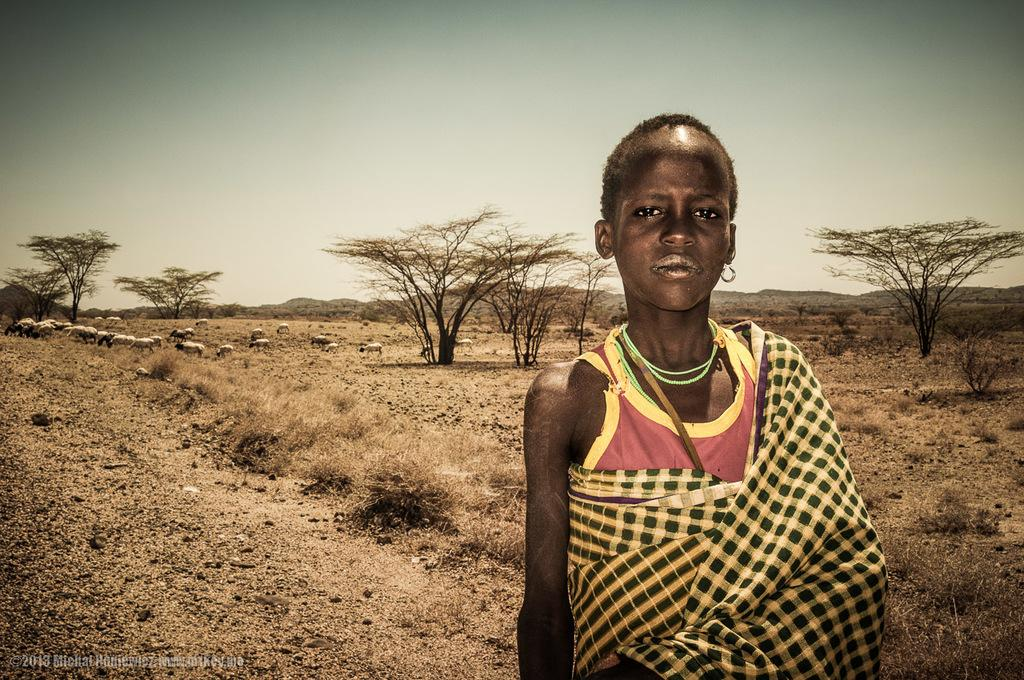What is the main subject of the image? There is a person in the image. What is the person wearing? The person is wearing a dress. Where is the person standing? The person is standing on the ground. What can be seen in the background of the image? There is a group of trees, animals, mountains, and the sky visible in the background of the image. What type of match is the person holding in the image? There is no match present in the image. How do the ducks contribute to the person's pleasure in the image? There are no ducks present in the image, so it is not possible to determine how they might contribute to the person's pleasure. 